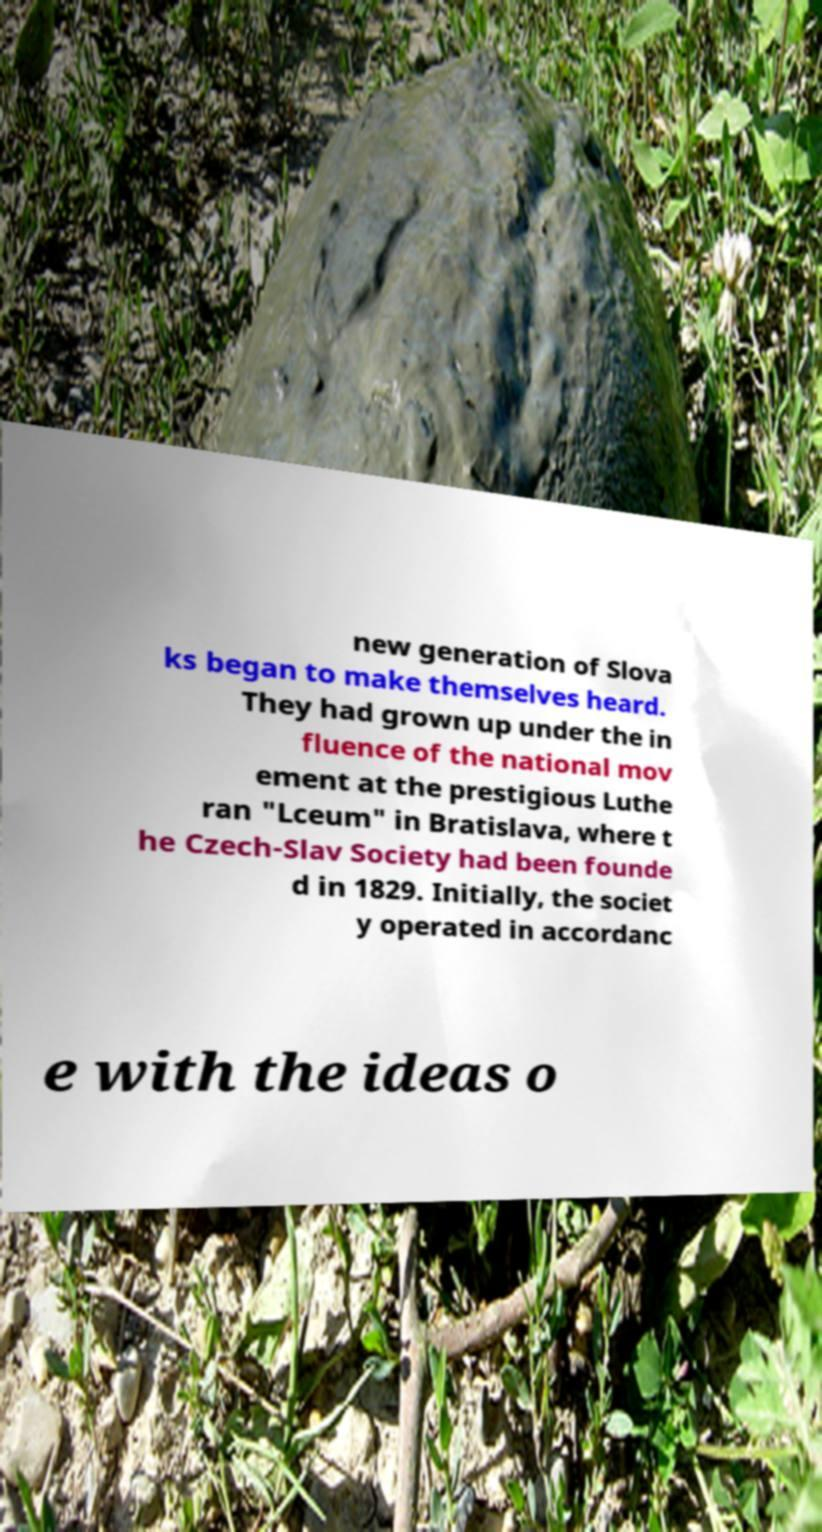Could you assist in decoding the text presented in this image and type it out clearly? new generation of Slova ks began to make themselves heard. They had grown up under the in fluence of the national mov ement at the prestigious Luthe ran "Lceum" in Bratislava, where t he Czech-Slav Society had been founde d in 1829. Initially, the societ y operated in accordanc e with the ideas o 